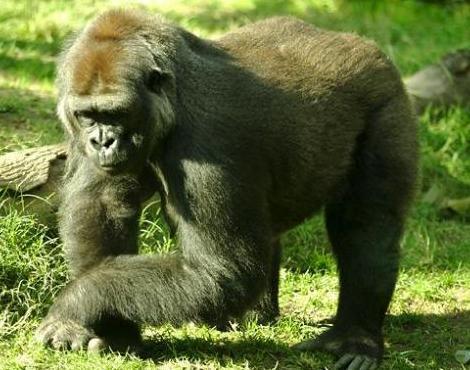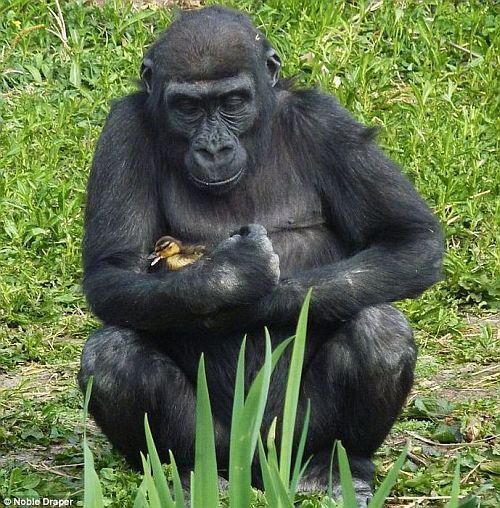The first image is the image on the left, the second image is the image on the right. Evaluate the accuracy of this statement regarding the images: "An image shows a gorilla sitting and holding a baby animal to its chest.". Is it true? Answer yes or no. Yes. The first image is the image on the left, the second image is the image on the right. For the images shown, is this caption "There are parts of at least four gorillas visible." true? Answer yes or no. No. 